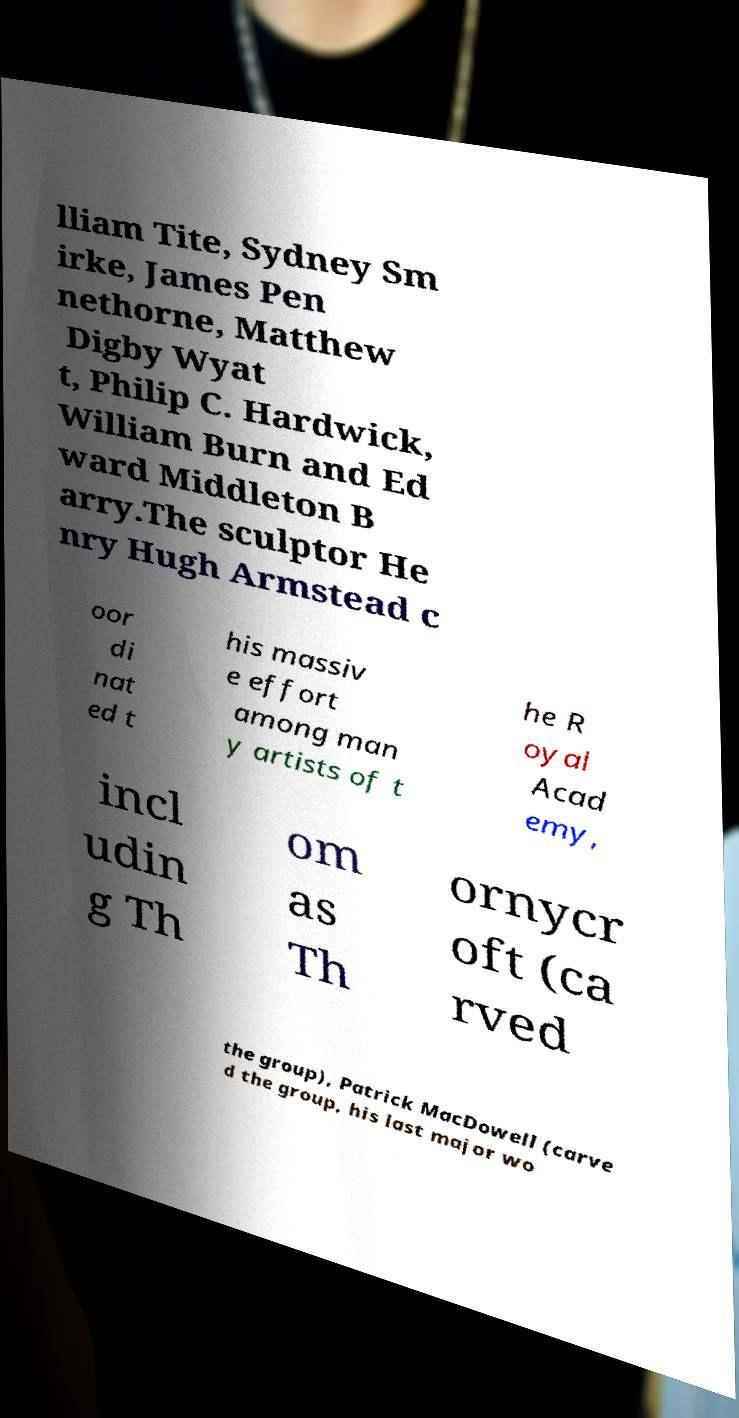Please read and relay the text visible in this image. What does it say? lliam Tite, Sydney Sm irke, James Pen nethorne, Matthew Digby Wyat t, Philip C. Hardwick, William Burn and Ed ward Middleton B arry.The sculptor He nry Hugh Armstead c oor di nat ed t his massiv e effort among man y artists of t he R oyal Acad emy, incl udin g Th om as Th ornycr oft (ca rved the group), Patrick MacDowell (carve d the group, his last major wo 